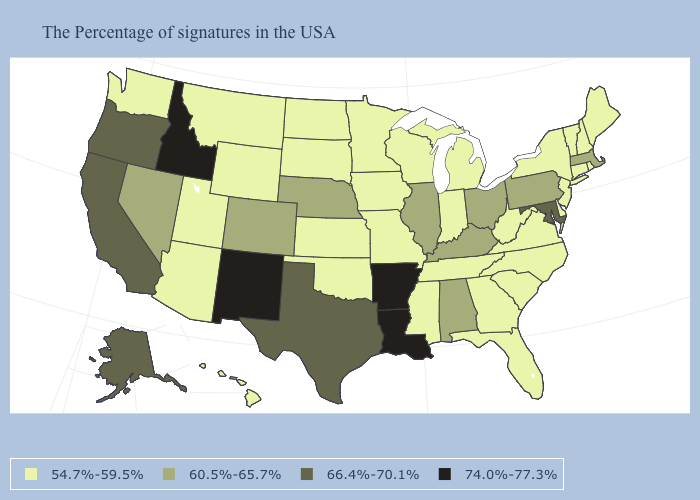What is the lowest value in states that border Montana?
Write a very short answer. 54.7%-59.5%. How many symbols are there in the legend?
Give a very brief answer. 4. Does Idaho have the highest value in the USA?
Answer briefly. Yes. What is the value of Virginia?
Give a very brief answer. 54.7%-59.5%. Name the states that have a value in the range 66.4%-70.1%?
Give a very brief answer. Maryland, Texas, California, Oregon, Alaska. Among the states that border New Jersey , does Delaware have the highest value?
Give a very brief answer. No. Name the states that have a value in the range 60.5%-65.7%?
Answer briefly. Massachusetts, Pennsylvania, Ohio, Kentucky, Alabama, Illinois, Nebraska, Colorado, Nevada. Which states have the lowest value in the West?
Keep it brief. Wyoming, Utah, Montana, Arizona, Washington, Hawaii. What is the lowest value in the USA?
Quick response, please. 54.7%-59.5%. What is the value of Michigan?
Concise answer only. 54.7%-59.5%. Name the states that have a value in the range 66.4%-70.1%?
Write a very short answer. Maryland, Texas, California, Oregon, Alaska. Does Washington have a higher value than Oregon?
Write a very short answer. No. What is the lowest value in states that border Indiana?
Give a very brief answer. 54.7%-59.5%. Name the states that have a value in the range 54.7%-59.5%?
Quick response, please. Maine, Rhode Island, New Hampshire, Vermont, Connecticut, New York, New Jersey, Delaware, Virginia, North Carolina, South Carolina, West Virginia, Florida, Georgia, Michigan, Indiana, Tennessee, Wisconsin, Mississippi, Missouri, Minnesota, Iowa, Kansas, Oklahoma, South Dakota, North Dakota, Wyoming, Utah, Montana, Arizona, Washington, Hawaii. Does the map have missing data?
Short answer required. No. 